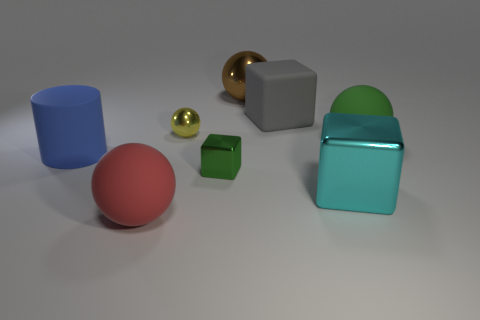Does the tiny metal cube have the same color as the matte sphere right of the brown shiny object?
Your answer should be very brief. Yes. Does the matte ball that is behind the blue cylinder have the same color as the cube left of the large gray block?
Your answer should be compact. Yes. What is the material of the big object that is the same color as the small block?
Ensure brevity in your answer.  Rubber. Are there any things that are to the left of the rubber ball on the right side of the large gray object?
Ensure brevity in your answer.  Yes. The object that is the same color as the tiny block is what size?
Your response must be concise. Large. What is the shape of the metallic thing that is behind the small shiny sphere?
Offer a terse response. Sphere. What number of rubber objects are right of the ball that is in front of the green thing behind the large blue thing?
Make the answer very short. 2. There is a gray cube; does it have the same size as the green object in front of the cylinder?
Provide a short and direct response. No. What size is the rubber ball to the right of the metal block that is on the right side of the brown metal object?
Give a very brief answer. Large. How many large gray things have the same material as the blue object?
Provide a short and direct response. 1. 